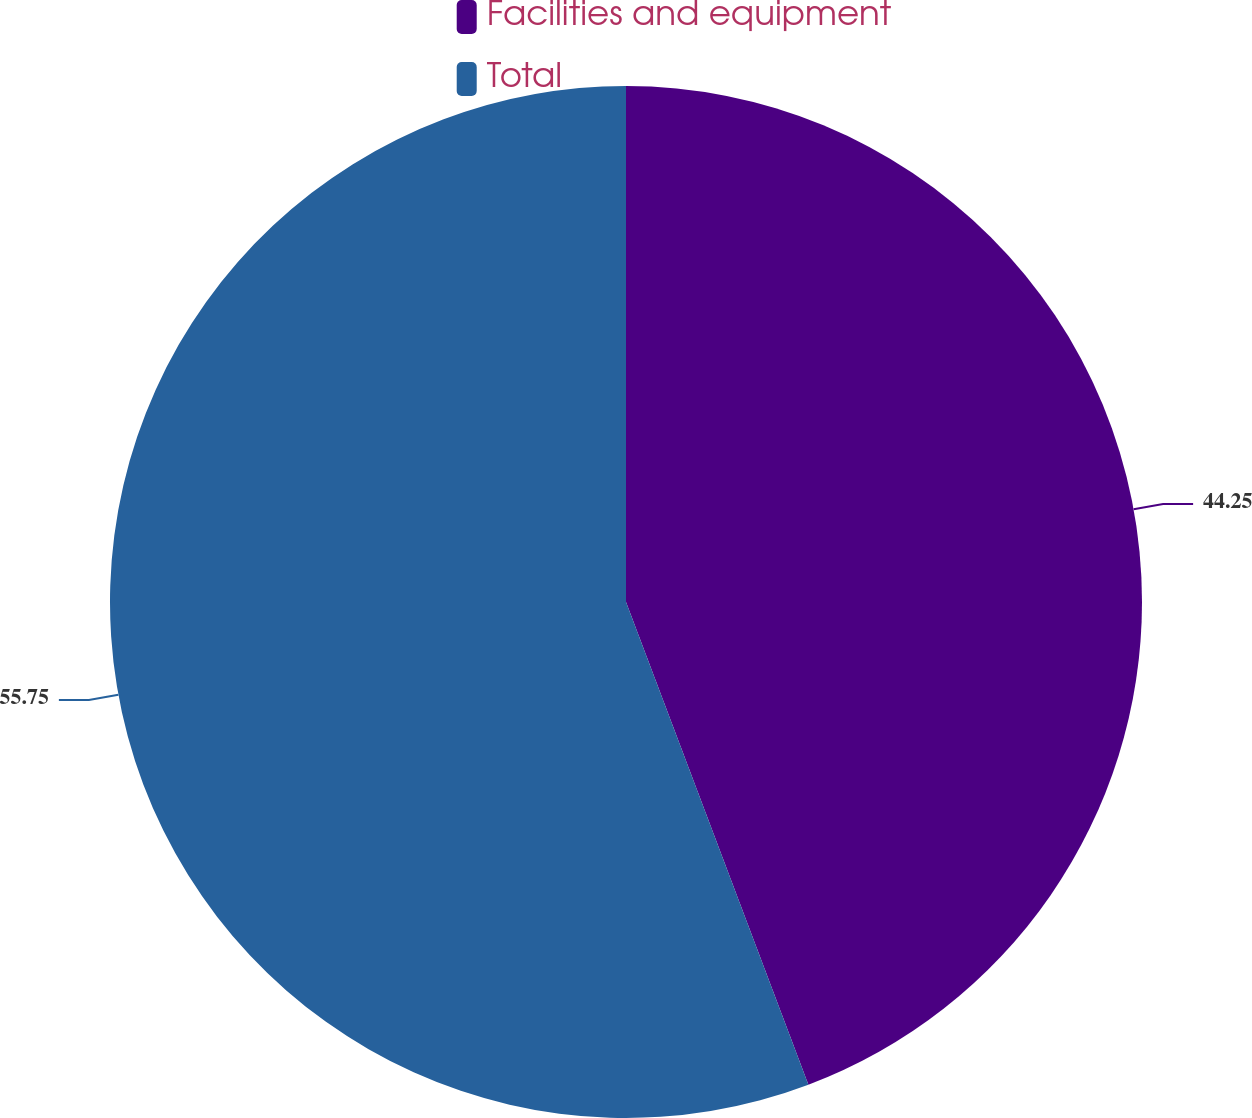Convert chart to OTSL. <chart><loc_0><loc_0><loc_500><loc_500><pie_chart><fcel>Facilities and equipment<fcel>Total<nl><fcel>44.25%<fcel>55.75%<nl></chart> 